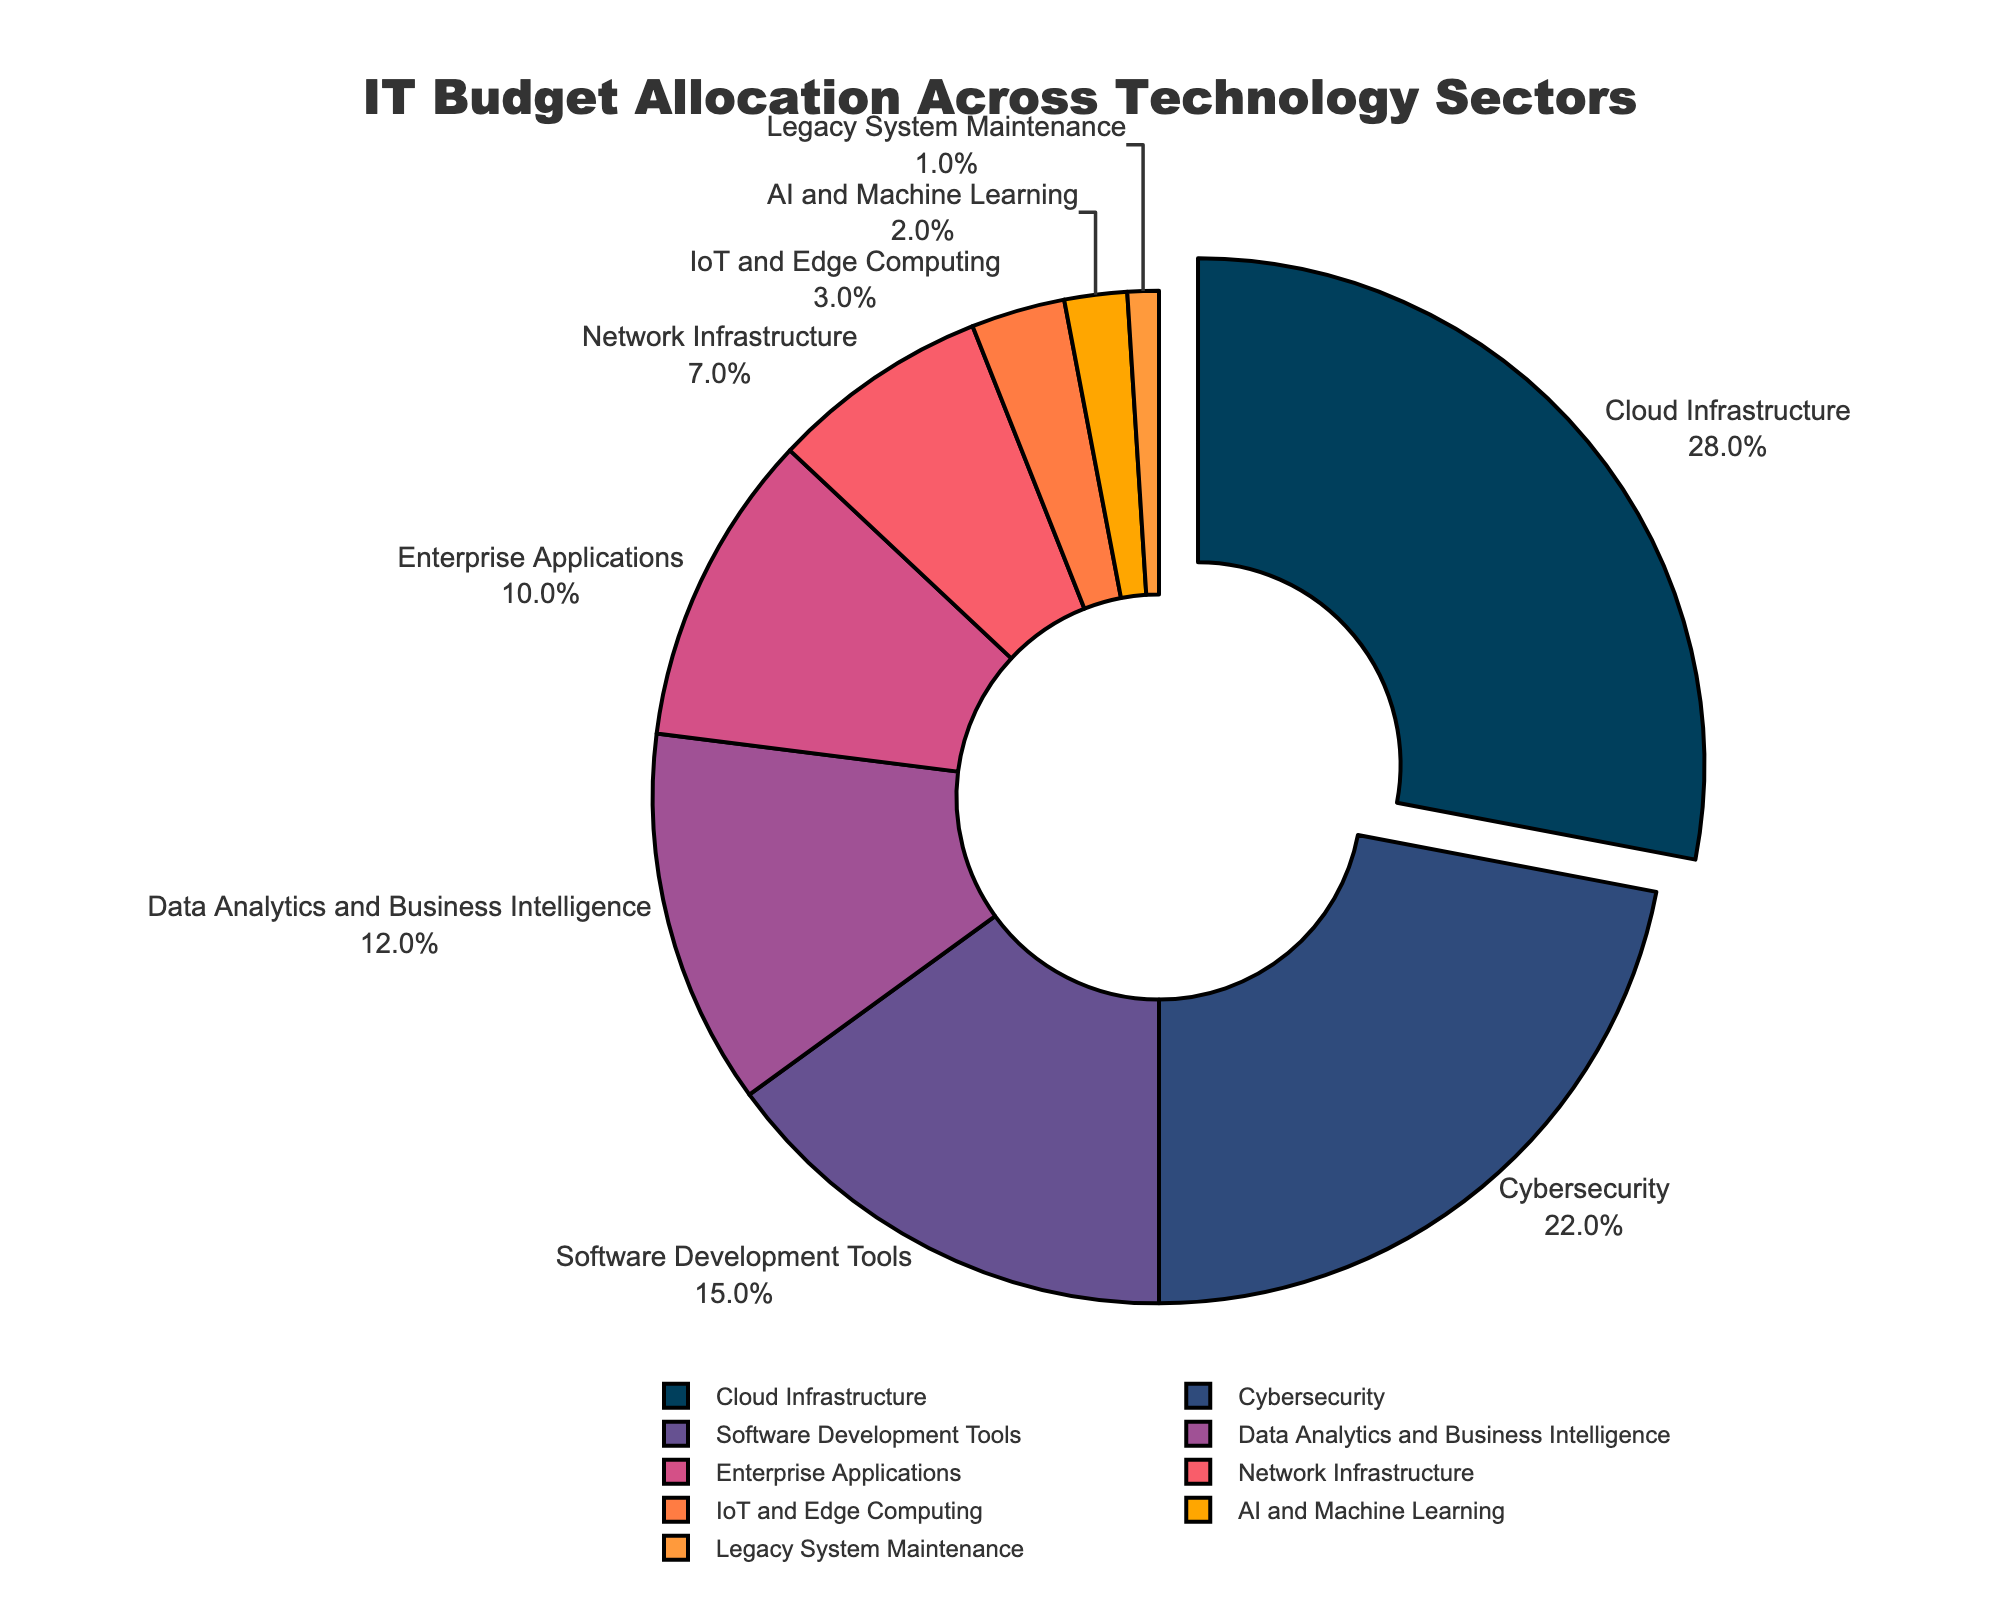What is the largest category in the IT budget allocation? By looking at the largest segment of the pie chart, we see that Cloud Infrastructure has the largest share.
Answer: Cloud Infrastructure Which category has a higher allocation, Cybersecurity or Software Development Tools? Comparing the sizes of their respective segments, Cybersecurity has a larger share (22%) than Software Development Tools (15%).
Answer: Cybersecurity What is the combined percentage of Cloud Infrastructure and Data Analytics and Business Intelligence? Adding the percentages for Cloud Infrastructure (28%) and Data Analytics and Business Intelligence (12%), we get 28 + 12 = 40.
Answer: 40% Which category constitutes the smallest portion of the IT budget? By identifying the smallest segment in the pie chart, we see that Legacy System Maintenance has the smallest share.
Answer: Legacy System Maintenance How much more is allocated to Enterprise Applications compared to IoT and Edge Computing? The percentage for Enterprise Applications is 10% and for IoT and Edge Computing is 3%. The difference is 10 - 3 = 7.
Answer: 7% Are there more funds allocated to Network Infrastructure or to Data Analytics and Business Intelligence? Comparing the sizes of their respective segments, Data Analytics and Business Intelligence (12%) has more allocation than Network Infrastructure (7%).
Answer: Data Analytics and Business Intelligence What is the sum of the percentages for categories allocated less than 10%? Adding the percentages of Network Infrastructure (7%), IoT and Edge Computing (3%), AI and Machine Learning (2%), and Legacy System Maintenance (1%), we get 7 + 3 + 2 + 1 = 13.
Answer: 13% What is the percentage allocated to AI and Machine Learning, and how does it compare visually? The allocation for AI and Machine Learning is 2%. Visually, this segment is one of the smallest sections in the pie chart, indicating a minimal share.
Answer: 2% What fraction of the budget is allocated to Enterprise Applications? Enterprise Applications are allocated 10%, which equates to 10/100 or 1/10 of the budget.
Answer: 1/10 